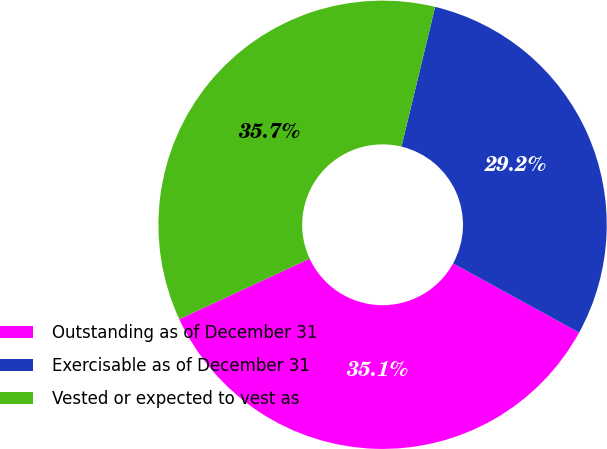Convert chart to OTSL. <chart><loc_0><loc_0><loc_500><loc_500><pie_chart><fcel>Outstanding as of December 31<fcel>Exercisable as of December 31<fcel>Vested or expected to vest as<nl><fcel>35.1%<fcel>29.22%<fcel>35.69%<nl></chart> 